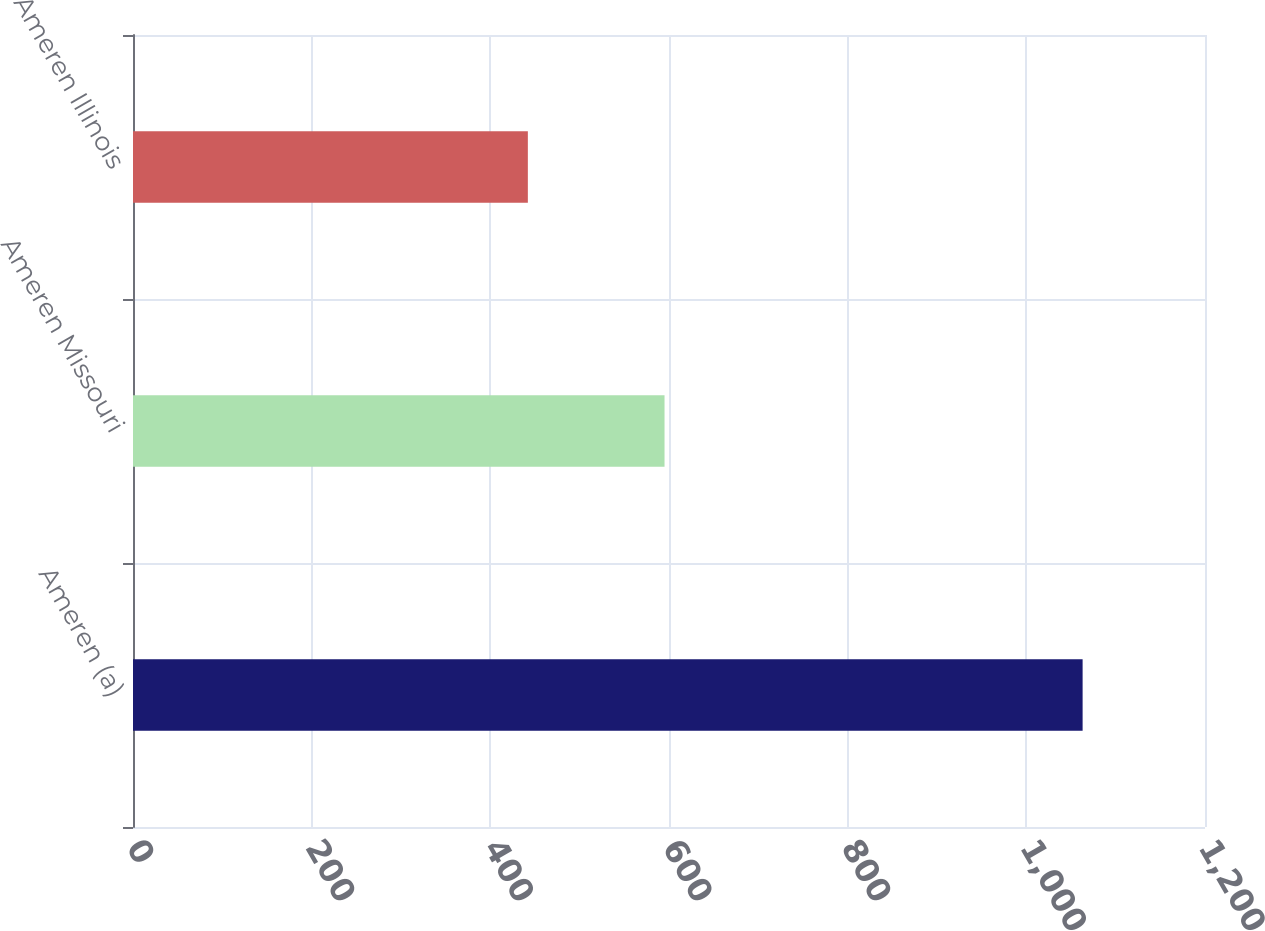Convert chart to OTSL. <chart><loc_0><loc_0><loc_500><loc_500><bar_chart><fcel>Ameren (a)<fcel>Ameren Missouri<fcel>Ameren Illinois<nl><fcel>1063<fcel>595<fcel>442<nl></chart> 